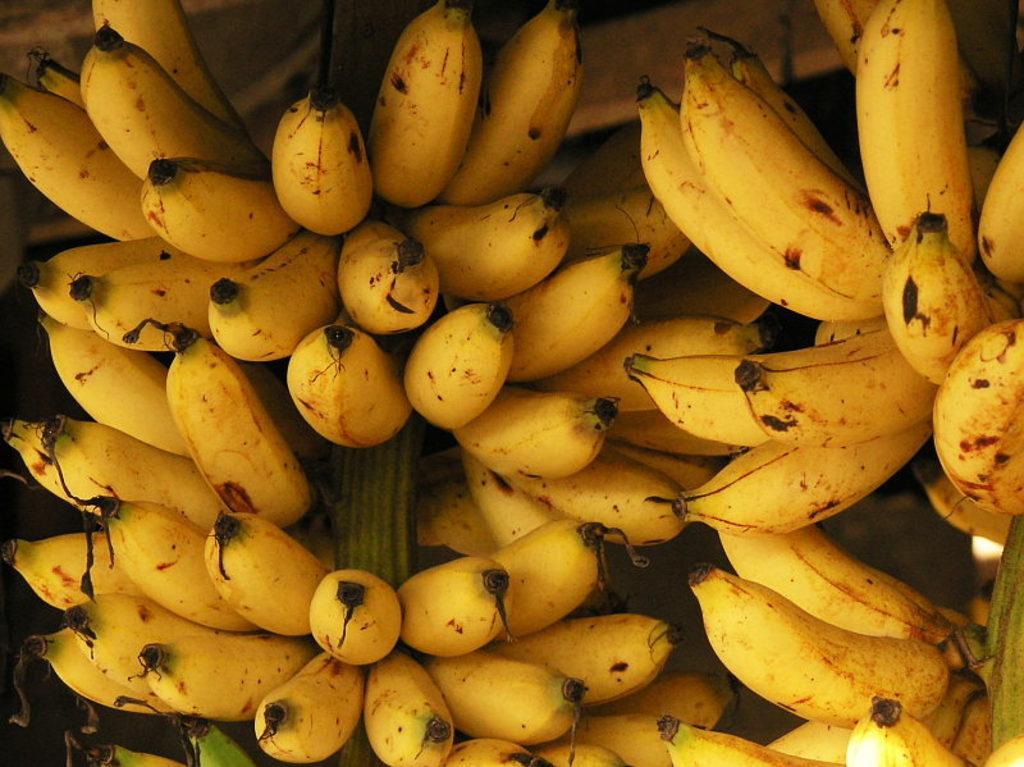Could you give a brief overview of what you see in this image? In this picture we can see bananas. 